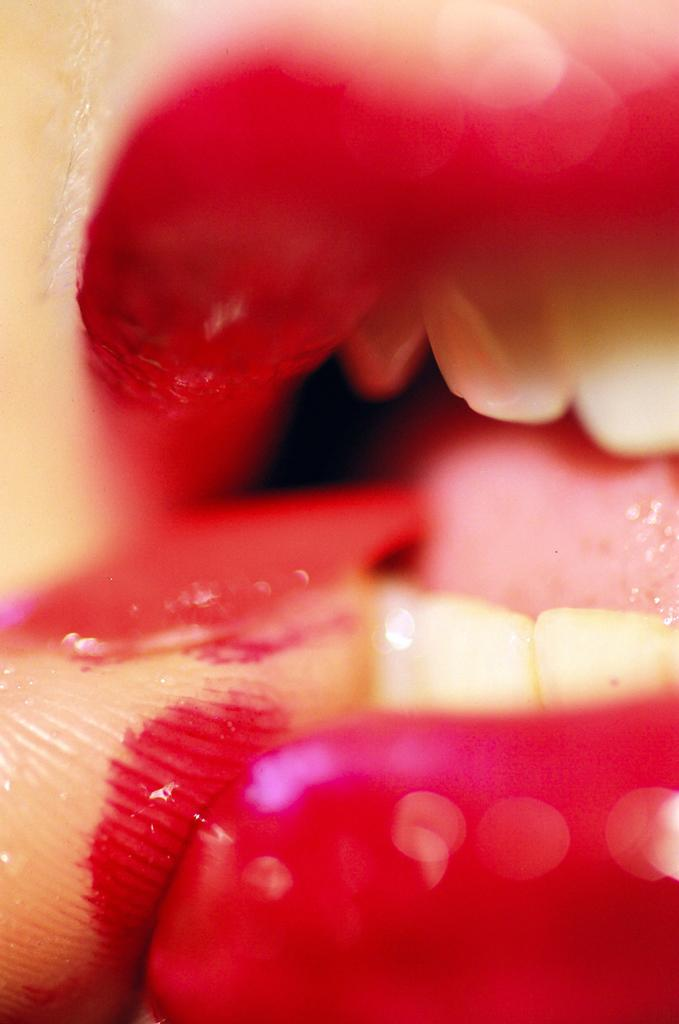What is the main subject of the image? There is a person in the image. What is the person doing in the image? The person has their finger in their mouth. What type of property does the person own in the image? There is no information about the person owning any property in the image. How many drops of water can be seen falling from the person's finger in the image? There is no mention of any drops of water in the image. 